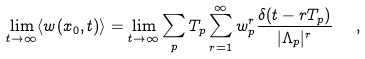Convert formula to latex. <formula><loc_0><loc_0><loc_500><loc_500>\lim _ { t \rightarrow \infty } \langle w ( x _ { 0 } , t ) \rangle = \lim _ { t \rightarrow \infty } \sum _ { p } T _ { p } \sum _ { r = 1 } ^ { \infty } w _ { p } ^ { r } \frac { \delta ( t - r T _ { p } ) } { | \Lambda _ { p } | ^ { r } } \ \ ,</formula> 